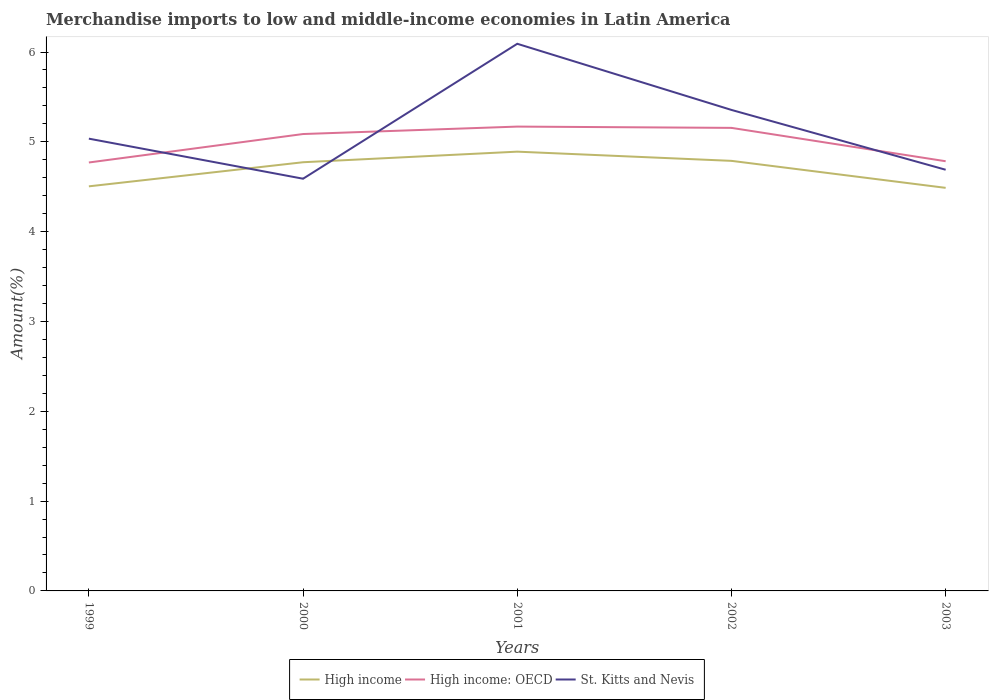Does the line corresponding to High income: OECD intersect with the line corresponding to High income?
Give a very brief answer. No. Across all years, what is the maximum percentage of amount earned from merchandise imports in St. Kitts and Nevis?
Give a very brief answer. 4.59. What is the total percentage of amount earned from merchandise imports in High income: OECD in the graph?
Make the answer very short. 0.37. What is the difference between the highest and the second highest percentage of amount earned from merchandise imports in High income?
Offer a very short reply. 0.4. What is the difference between the highest and the lowest percentage of amount earned from merchandise imports in High income: OECD?
Ensure brevity in your answer.  3. What is the difference between two consecutive major ticks on the Y-axis?
Make the answer very short. 1. Does the graph contain any zero values?
Provide a succinct answer. No. Where does the legend appear in the graph?
Offer a very short reply. Bottom center. How are the legend labels stacked?
Offer a terse response. Horizontal. What is the title of the graph?
Offer a very short reply. Merchandise imports to low and middle-income economies in Latin America. Does "St. Vincent and the Grenadines" appear as one of the legend labels in the graph?
Your answer should be compact. No. What is the label or title of the Y-axis?
Provide a short and direct response. Amount(%). What is the Amount(%) in High income in 1999?
Offer a terse response. 4.5. What is the Amount(%) of High income: OECD in 1999?
Give a very brief answer. 4.77. What is the Amount(%) in St. Kitts and Nevis in 1999?
Provide a short and direct response. 5.04. What is the Amount(%) of High income in 2000?
Ensure brevity in your answer.  4.77. What is the Amount(%) in High income: OECD in 2000?
Make the answer very short. 5.09. What is the Amount(%) of St. Kitts and Nevis in 2000?
Provide a short and direct response. 4.59. What is the Amount(%) in High income in 2001?
Your response must be concise. 4.89. What is the Amount(%) in High income: OECD in 2001?
Ensure brevity in your answer.  5.17. What is the Amount(%) of St. Kitts and Nevis in 2001?
Offer a very short reply. 6.09. What is the Amount(%) of High income in 2002?
Provide a short and direct response. 4.79. What is the Amount(%) of High income: OECD in 2002?
Make the answer very short. 5.16. What is the Amount(%) in St. Kitts and Nevis in 2002?
Your answer should be very brief. 5.36. What is the Amount(%) in High income in 2003?
Your answer should be compact. 4.49. What is the Amount(%) in High income: OECD in 2003?
Your answer should be very brief. 4.78. What is the Amount(%) in St. Kitts and Nevis in 2003?
Offer a very short reply. 4.69. Across all years, what is the maximum Amount(%) of High income?
Your answer should be very brief. 4.89. Across all years, what is the maximum Amount(%) of High income: OECD?
Offer a very short reply. 5.17. Across all years, what is the maximum Amount(%) in St. Kitts and Nevis?
Keep it short and to the point. 6.09. Across all years, what is the minimum Amount(%) in High income?
Offer a terse response. 4.49. Across all years, what is the minimum Amount(%) in High income: OECD?
Ensure brevity in your answer.  4.77. Across all years, what is the minimum Amount(%) in St. Kitts and Nevis?
Ensure brevity in your answer.  4.59. What is the total Amount(%) of High income in the graph?
Provide a short and direct response. 23.44. What is the total Amount(%) in High income: OECD in the graph?
Offer a very short reply. 24.97. What is the total Amount(%) in St. Kitts and Nevis in the graph?
Ensure brevity in your answer.  25.76. What is the difference between the Amount(%) of High income in 1999 and that in 2000?
Ensure brevity in your answer.  -0.27. What is the difference between the Amount(%) of High income: OECD in 1999 and that in 2000?
Ensure brevity in your answer.  -0.32. What is the difference between the Amount(%) in St. Kitts and Nevis in 1999 and that in 2000?
Keep it short and to the point. 0.45. What is the difference between the Amount(%) of High income in 1999 and that in 2001?
Ensure brevity in your answer.  -0.39. What is the difference between the Amount(%) of High income: OECD in 1999 and that in 2001?
Give a very brief answer. -0.4. What is the difference between the Amount(%) in St. Kitts and Nevis in 1999 and that in 2001?
Make the answer very short. -1.06. What is the difference between the Amount(%) of High income in 1999 and that in 2002?
Ensure brevity in your answer.  -0.28. What is the difference between the Amount(%) of High income: OECD in 1999 and that in 2002?
Provide a succinct answer. -0.39. What is the difference between the Amount(%) in St. Kitts and Nevis in 1999 and that in 2002?
Keep it short and to the point. -0.32. What is the difference between the Amount(%) of High income in 1999 and that in 2003?
Your answer should be compact. 0.02. What is the difference between the Amount(%) in High income: OECD in 1999 and that in 2003?
Offer a very short reply. -0.01. What is the difference between the Amount(%) in St. Kitts and Nevis in 1999 and that in 2003?
Your answer should be compact. 0.35. What is the difference between the Amount(%) of High income in 2000 and that in 2001?
Keep it short and to the point. -0.12. What is the difference between the Amount(%) in High income: OECD in 2000 and that in 2001?
Make the answer very short. -0.08. What is the difference between the Amount(%) of St. Kitts and Nevis in 2000 and that in 2001?
Make the answer very short. -1.5. What is the difference between the Amount(%) of High income in 2000 and that in 2002?
Your answer should be compact. -0.02. What is the difference between the Amount(%) in High income: OECD in 2000 and that in 2002?
Give a very brief answer. -0.07. What is the difference between the Amount(%) in St. Kitts and Nevis in 2000 and that in 2002?
Ensure brevity in your answer.  -0.77. What is the difference between the Amount(%) of High income in 2000 and that in 2003?
Your answer should be compact. 0.29. What is the difference between the Amount(%) of High income: OECD in 2000 and that in 2003?
Ensure brevity in your answer.  0.3. What is the difference between the Amount(%) in High income in 2001 and that in 2002?
Your answer should be compact. 0.1. What is the difference between the Amount(%) in High income: OECD in 2001 and that in 2002?
Offer a terse response. 0.01. What is the difference between the Amount(%) of St. Kitts and Nevis in 2001 and that in 2002?
Provide a succinct answer. 0.74. What is the difference between the Amount(%) in High income in 2001 and that in 2003?
Give a very brief answer. 0.4. What is the difference between the Amount(%) in High income: OECD in 2001 and that in 2003?
Make the answer very short. 0.39. What is the difference between the Amount(%) in St. Kitts and Nevis in 2001 and that in 2003?
Your response must be concise. 1.4. What is the difference between the Amount(%) of High income in 2002 and that in 2003?
Ensure brevity in your answer.  0.3. What is the difference between the Amount(%) in High income: OECD in 2002 and that in 2003?
Provide a succinct answer. 0.37. What is the difference between the Amount(%) in St. Kitts and Nevis in 2002 and that in 2003?
Your response must be concise. 0.67. What is the difference between the Amount(%) in High income in 1999 and the Amount(%) in High income: OECD in 2000?
Ensure brevity in your answer.  -0.58. What is the difference between the Amount(%) in High income in 1999 and the Amount(%) in St. Kitts and Nevis in 2000?
Provide a short and direct response. -0.08. What is the difference between the Amount(%) of High income: OECD in 1999 and the Amount(%) of St. Kitts and Nevis in 2000?
Offer a terse response. 0.18. What is the difference between the Amount(%) of High income in 1999 and the Amount(%) of High income: OECD in 2001?
Provide a succinct answer. -0.67. What is the difference between the Amount(%) of High income in 1999 and the Amount(%) of St. Kitts and Nevis in 2001?
Keep it short and to the point. -1.59. What is the difference between the Amount(%) in High income: OECD in 1999 and the Amount(%) in St. Kitts and Nevis in 2001?
Make the answer very short. -1.32. What is the difference between the Amount(%) of High income in 1999 and the Amount(%) of High income: OECD in 2002?
Give a very brief answer. -0.65. What is the difference between the Amount(%) of High income in 1999 and the Amount(%) of St. Kitts and Nevis in 2002?
Your answer should be very brief. -0.85. What is the difference between the Amount(%) of High income: OECD in 1999 and the Amount(%) of St. Kitts and Nevis in 2002?
Offer a terse response. -0.59. What is the difference between the Amount(%) in High income in 1999 and the Amount(%) in High income: OECD in 2003?
Keep it short and to the point. -0.28. What is the difference between the Amount(%) of High income in 1999 and the Amount(%) of St. Kitts and Nevis in 2003?
Your answer should be very brief. -0.18. What is the difference between the Amount(%) in High income: OECD in 1999 and the Amount(%) in St. Kitts and Nevis in 2003?
Provide a succinct answer. 0.08. What is the difference between the Amount(%) in High income in 2000 and the Amount(%) in High income: OECD in 2001?
Your answer should be compact. -0.4. What is the difference between the Amount(%) in High income in 2000 and the Amount(%) in St. Kitts and Nevis in 2001?
Give a very brief answer. -1.32. What is the difference between the Amount(%) of High income: OECD in 2000 and the Amount(%) of St. Kitts and Nevis in 2001?
Your answer should be compact. -1. What is the difference between the Amount(%) of High income in 2000 and the Amount(%) of High income: OECD in 2002?
Make the answer very short. -0.38. What is the difference between the Amount(%) in High income in 2000 and the Amount(%) in St. Kitts and Nevis in 2002?
Make the answer very short. -0.58. What is the difference between the Amount(%) in High income: OECD in 2000 and the Amount(%) in St. Kitts and Nevis in 2002?
Provide a short and direct response. -0.27. What is the difference between the Amount(%) of High income in 2000 and the Amount(%) of High income: OECD in 2003?
Offer a very short reply. -0.01. What is the difference between the Amount(%) of High income in 2000 and the Amount(%) of St. Kitts and Nevis in 2003?
Your response must be concise. 0.08. What is the difference between the Amount(%) in High income: OECD in 2000 and the Amount(%) in St. Kitts and Nevis in 2003?
Give a very brief answer. 0.4. What is the difference between the Amount(%) of High income in 2001 and the Amount(%) of High income: OECD in 2002?
Keep it short and to the point. -0.26. What is the difference between the Amount(%) of High income in 2001 and the Amount(%) of St. Kitts and Nevis in 2002?
Ensure brevity in your answer.  -0.46. What is the difference between the Amount(%) of High income: OECD in 2001 and the Amount(%) of St. Kitts and Nevis in 2002?
Provide a succinct answer. -0.19. What is the difference between the Amount(%) of High income in 2001 and the Amount(%) of High income: OECD in 2003?
Give a very brief answer. 0.11. What is the difference between the Amount(%) in High income in 2001 and the Amount(%) in St. Kitts and Nevis in 2003?
Keep it short and to the point. 0.2. What is the difference between the Amount(%) of High income: OECD in 2001 and the Amount(%) of St. Kitts and Nevis in 2003?
Your answer should be compact. 0.48. What is the difference between the Amount(%) of High income in 2002 and the Amount(%) of High income: OECD in 2003?
Keep it short and to the point. 0. What is the difference between the Amount(%) in High income in 2002 and the Amount(%) in St. Kitts and Nevis in 2003?
Provide a succinct answer. 0.1. What is the difference between the Amount(%) of High income: OECD in 2002 and the Amount(%) of St. Kitts and Nevis in 2003?
Give a very brief answer. 0.47. What is the average Amount(%) in High income per year?
Provide a short and direct response. 4.69. What is the average Amount(%) of High income: OECD per year?
Offer a terse response. 4.99. What is the average Amount(%) in St. Kitts and Nevis per year?
Ensure brevity in your answer.  5.15. In the year 1999, what is the difference between the Amount(%) of High income and Amount(%) of High income: OECD?
Offer a very short reply. -0.27. In the year 1999, what is the difference between the Amount(%) of High income and Amount(%) of St. Kitts and Nevis?
Provide a short and direct response. -0.53. In the year 1999, what is the difference between the Amount(%) in High income: OECD and Amount(%) in St. Kitts and Nevis?
Offer a very short reply. -0.27. In the year 2000, what is the difference between the Amount(%) in High income and Amount(%) in High income: OECD?
Give a very brief answer. -0.31. In the year 2000, what is the difference between the Amount(%) in High income and Amount(%) in St. Kitts and Nevis?
Make the answer very short. 0.18. In the year 2000, what is the difference between the Amount(%) in High income: OECD and Amount(%) in St. Kitts and Nevis?
Ensure brevity in your answer.  0.5. In the year 2001, what is the difference between the Amount(%) in High income and Amount(%) in High income: OECD?
Make the answer very short. -0.28. In the year 2001, what is the difference between the Amount(%) in High income and Amount(%) in St. Kitts and Nevis?
Provide a short and direct response. -1.2. In the year 2001, what is the difference between the Amount(%) in High income: OECD and Amount(%) in St. Kitts and Nevis?
Offer a terse response. -0.92. In the year 2002, what is the difference between the Amount(%) in High income and Amount(%) in High income: OECD?
Your response must be concise. -0.37. In the year 2002, what is the difference between the Amount(%) in High income and Amount(%) in St. Kitts and Nevis?
Ensure brevity in your answer.  -0.57. In the year 2002, what is the difference between the Amount(%) of High income: OECD and Amount(%) of St. Kitts and Nevis?
Make the answer very short. -0.2. In the year 2003, what is the difference between the Amount(%) in High income and Amount(%) in High income: OECD?
Offer a very short reply. -0.3. In the year 2003, what is the difference between the Amount(%) in High income and Amount(%) in St. Kitts and Nevis?
Provide a succinct answer. -0.2. In the year 2003, what is the difference between the Amount(%) of High income: OECD and Amount(%) of St. Kitts and Nevis?
Your response must be concise. 0.09. What is the ratio of the Amount(%) in High income in 1999 to that in 2000?
Your response must be concise. 0.94. What is the ratio of the Amount(%) of High income: OECD in 1999 to that in 2000?
Offer a terse response. 0.94. What is the ratio of the Amount(%) in St. Kitts and Nevis in 1999 to that in 2000?
Your answer should be compact. 1.1. What is the ratio of the Amount(%) in High income in 1999 to that in 2001?
Offer a very short reply. 0.92. What is the ratio of the Amount(%) of High income: OECD in 1999 to that in 2001?
Your answer should be compact. 0.92. What is the ratio of the Amount(%) in St. Kitts and Nevis in 1999 to that in 2001?
Make the answer very short. 0.83. What is the ratio of the Amount(%) of High income in 1999 to that in 2002?
Your answer should be very brief. 0.94. What is the ratio of the Amount(%) in High income: OECD in 1999 to that in 2002?
Provide a short and direct response. 0.93. What is the ratio of the Amount(%) in St. Kitts and Nevis in 1999 to that in 2002?
Keep it short and to the point. 0.94. What is the ratio of the Amount(%) of High income in 1999 to that in 2003?
Your answer should be very brief. 1. What is the ratio of the Amount(%) of High income: OECD in 1999 to that in 2003?
Make the answer very short. 1. What is the ratio of the Amount(%) in St. Kitts and Nevis in 1999 to that in 2003?
Make the answer very short. 1.07. What is the ratio of the Amount(%) of High income in 2000 to that in 2001?
Make the answer very short. 0.98. What is the ratio of the Amount(%) of High income: OECD in 2000 to that in 2001?
Provide a short and direct response. 0.98. What is the ratio of the Amount(%) in St. Kitts and Nevis in 2000 to that in 2001?
Provide a succinct answer. 0.75. What is the ratio of the Amount(%) of High income: OECD in 2000 to that in 2002?
Your answer should be compact. 0.99. What is the ratio of the Amount(%) of St. Kitts and Nevis in 2000 to that in 2002?
Your answer should be very brief. 0.86. What is the ratio of the Amount(%) in High income in 2000 to that in 2003?
Your response must be concise. 1.06. What is the ratio of the Amount(%) of High income: OECD in 2000 to that in 2003?
Provide a succinct answer. 1.06. What is the ratio of the Amount(%) in St. Kitts and Nevis in 2000 to that in 2003?
Keep it short and to the point. 0.98. What is the ratio of the Amount(%) of High income in 2001 to that in 2002?
Offer a very short reply. 1.02. What is the ratio of the Amount(%) in St. Kitts and Nevis in 2001 to that in 2002?
Make the answer very short. 1.14. What is the ratio of the Amount(%) in High income in 2001 to that in 2003?
Your answer should be compact. 1.09. What is the ratio of the Amount(%) in High income: OECD in 2001 to that in 2003?
Your answer should be very brief. 1.08. What is the ratio of the Amount(%) in St. Kitts and Nevis in 2001 to that in 2003?
Your answer should be very brief. 1.3. What is the ratio of the Amount(%) of High income in 2002 to that in 2003?
Ensure brevity in your answer.  1.07. What is the ratio of the Amount(%) of High income: OECD in 2002 to that in 2003?
Your response must be concise. 1.08. What is the ratio of the Amount(%) of St. Kitts and Nevis in 2002 to that in 2003?
Your response must be concise. 1.14. What is the difference between the highest and the second highest Amount(%) in High income?
Provide a succinct answer. 0.1. What is the difference between the highest and the second highest Amount(%) in High income: OECD?
Keep it short and to the point. 0.01. What is the difference between the highest and the second highest Amount(%) of St. Kitts and Nevis?
Provide a succinct answer. 0.74. What is the difference between the highest and the lowest Amount(%) in High income?
Offer a terse response. 0.4. What is the difference between the highest and the lowest Amount(%) of High income: OECD?
Provide a succinct answer. 0.4. What is the difference between the highest and the lowest Amount(%) of St. Kitts and Nevis?
Ensure brevity in your answer.  1.5. 